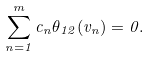Convert formula to latex. <formula><loc_0><loc_0><loc_500><loc_500>\sum _ { n = 1 } ^ { m } c _ { n } \theta _ { 1 2 } ( v _ { n } ) = 0 .</formula> 